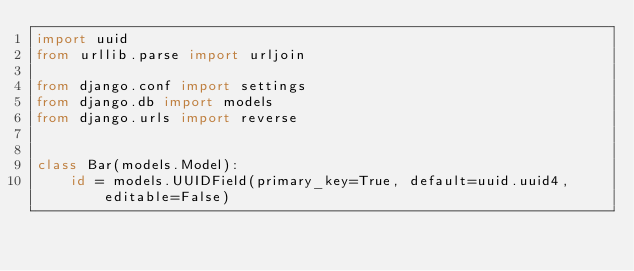Convert code to text. <code><loc_0><loc_0><loc_500><loc_500><_Python_>import uuid
from urllib.parse import urljoin

from django.conf import settings
from django.db import models
from django.urls import reverse


class Bar(models.Model):
    id = models.UUIDField(primary_key=True, default=uuid.uuid4, editable=False)
    </code> 